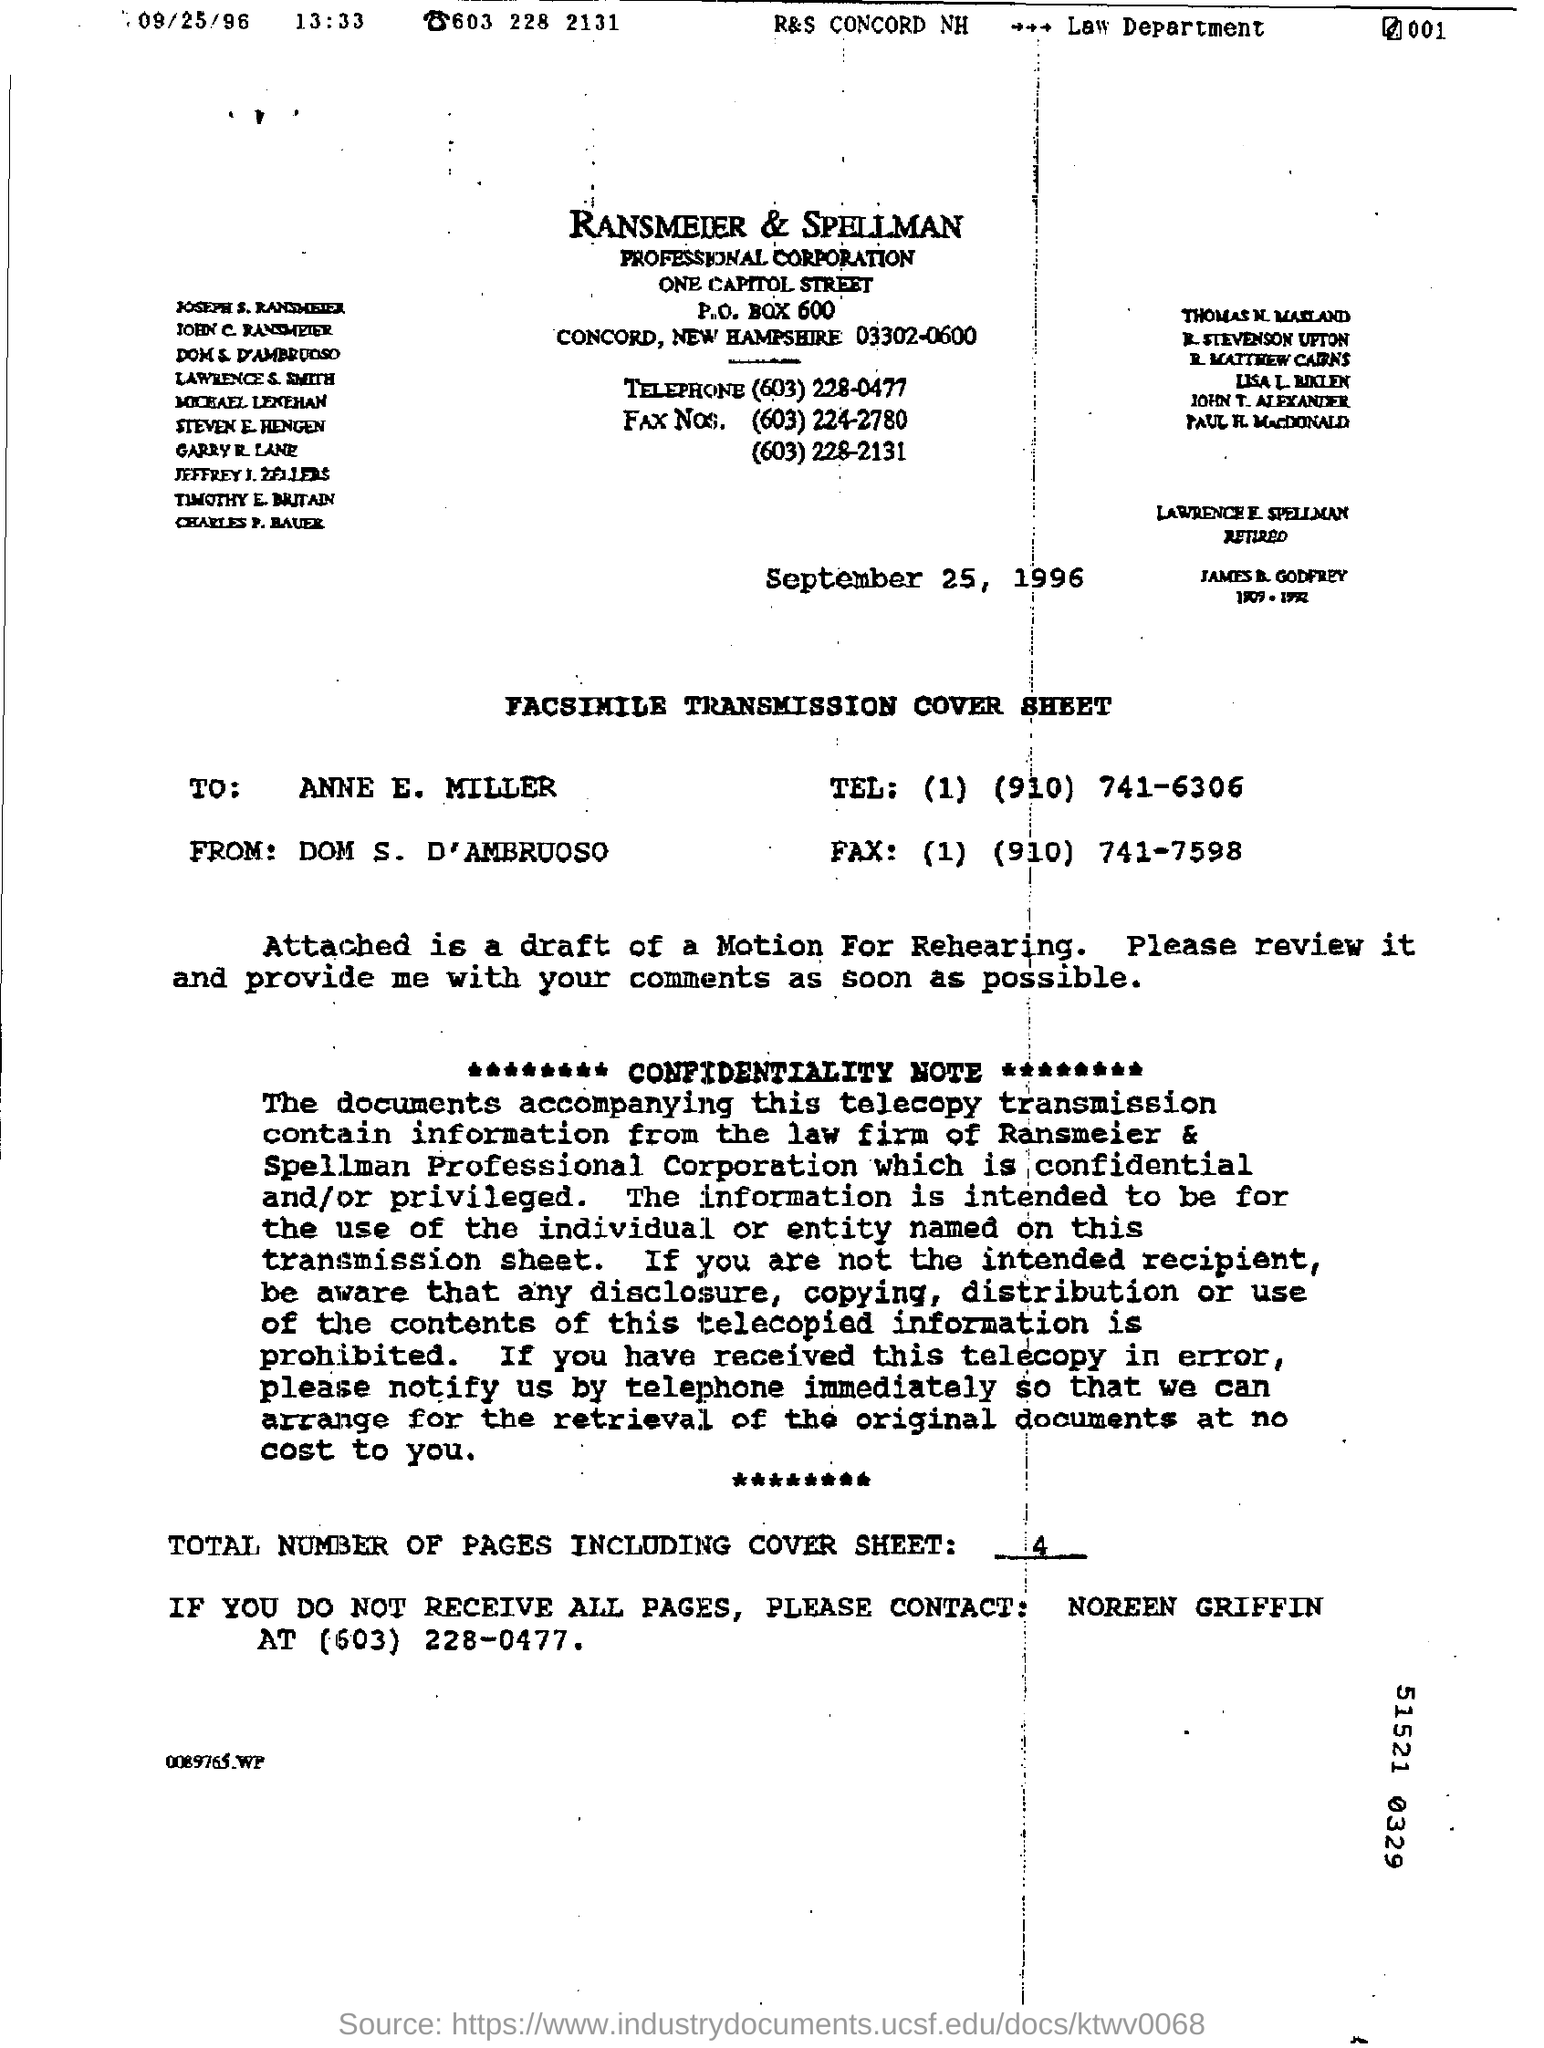Who is the sender of the Fax?
Give a very brief answer. DOM S. D'AMBRUOSO. To whom, the Fax is being sent?
Make the answer very short. Anne E. Miller. What is the total number of pages in the fax including cover sheet?
Provide a short and direct response. 4. 